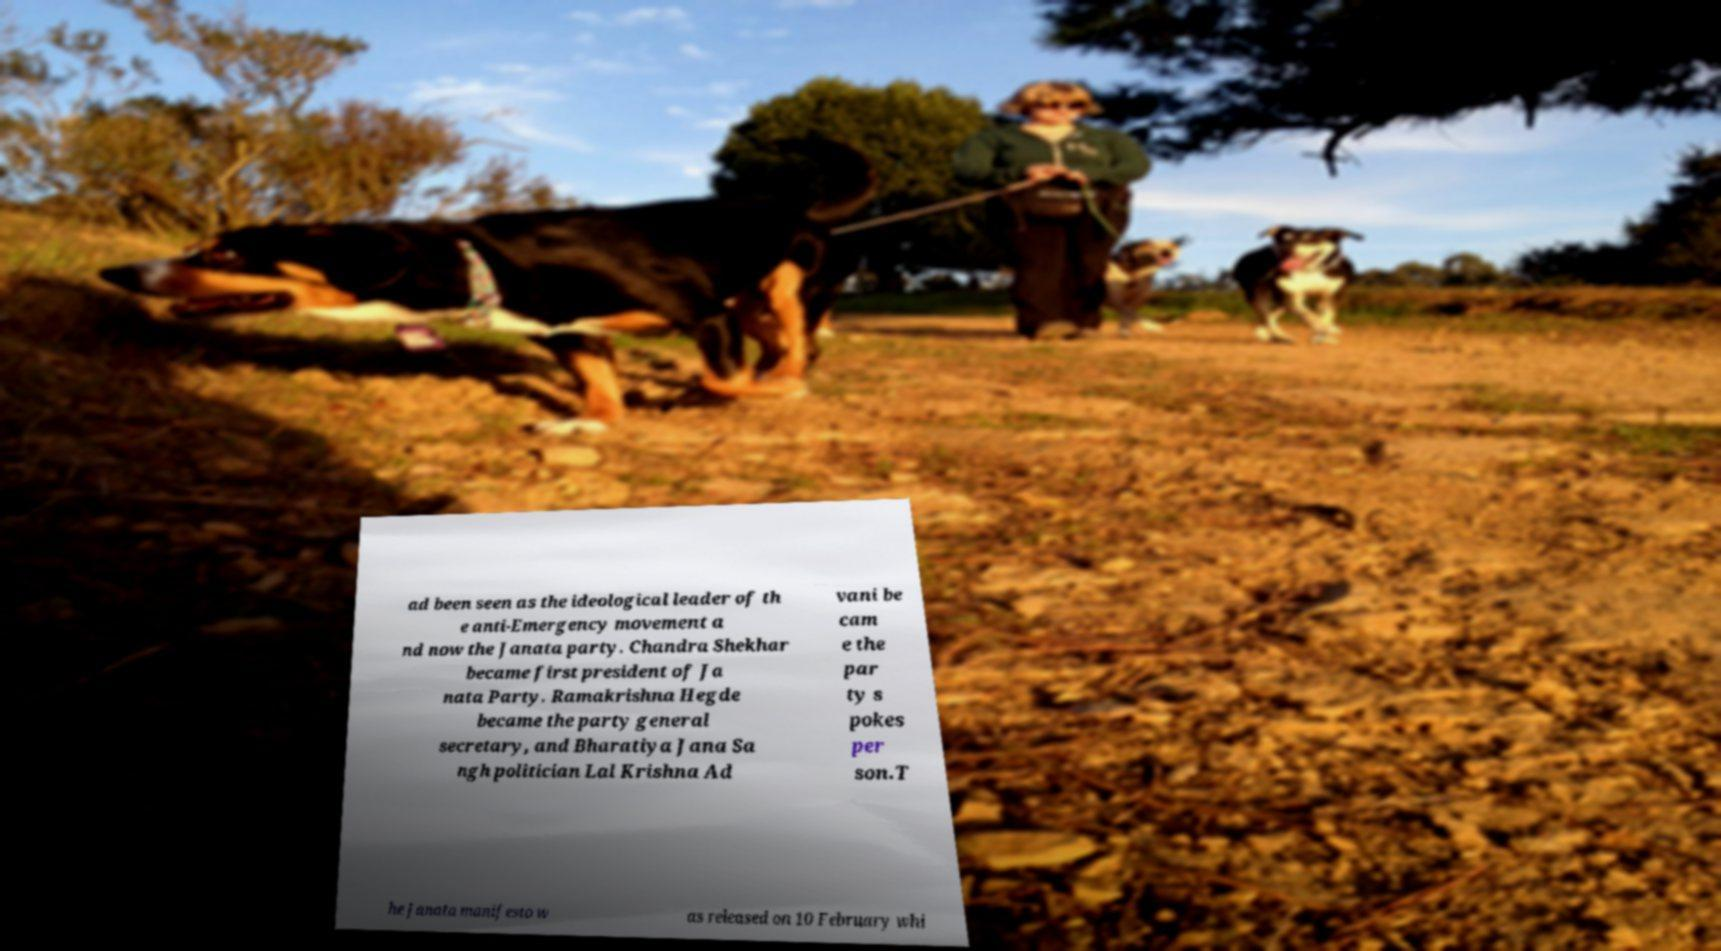Can you read and provide the text displayed in the image?This photo seems to have some interesting text. Can you extract and type it out for me? ad been seen as the ideological leader of th e anti-Emergency movement a nd now the Janata party. Chandra Shekhar became first president of Ja nata Party. Ramakrishna Hegde became the party general secretary, and Bharatiya Jana Sa ngh politician Lal Krishna Ad vani be cam e the par ty s pokes per son.T he Janata manifesto w as released on 10 February whi 